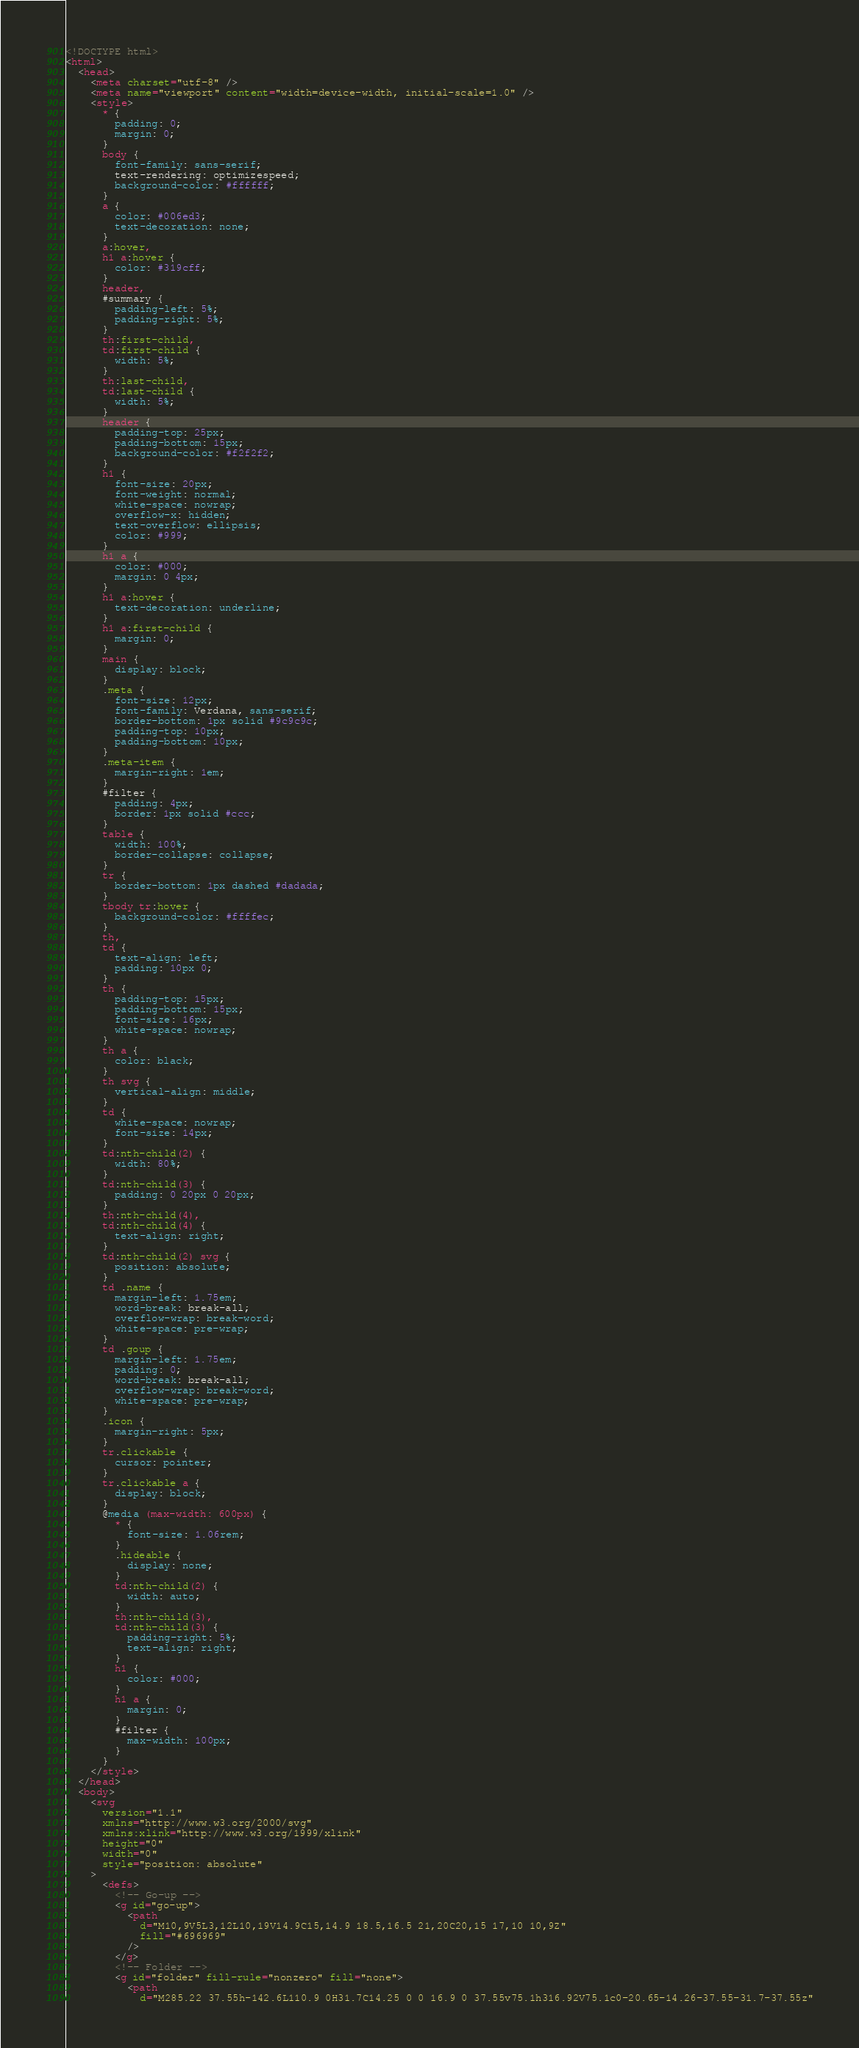Convert code to text. <code><loc_0><loc_0><loc_500><loc_500><_HTML_><!DOCTYPE html>
<html>
  <head>
    <meta charset="utf-8" />
    <meta name="viewport" content="width=device-width, initial-scale=1.0" />
    <style>
      * {
        padding: 0;
        margin: 0;
      }
      body {
        font-family: sans-serif;
        text-rendering: optimizespeed;
        background-color: #ffffff;
      }
      a {
        color: #006ed3;
        text-decoration: none;
      }
      a:hover,
      h1 a:hover {
        color: #319cff;
      }
      header,
      #summary {
        padding-left: 5%;
        padding-right: 5%;
      }
      th:first-child,
      td:first-child {
        width: 5%;
      }
      th:last-child,
      td:last-child {
        width: 5%;
      }
      header {
        padding-top: 25px;
        padding-bottom: 15px;
        background-color: #f2f2f2;
      }
      h1 {
        font-size: 20px;
        font-weight: normal;
        white-space: nowrap;
        overflow-x: hidden;
        text-overflow: ellipsis;
        color: #999;
      }
      h1 a {
        color: #000;
        margin: 0 4px;
      }
      h1 a:hover {
        text-decoration: underline;
      }
      h1 a:first-child {
        margin: 0;
      }
      main {
        display: block;
      }
      .meta {
        font-size: 12px;
        font-family: Verdana, sans-serif;
        border-bottom: 1px solid #9c9c9c;
        padding-top: 10px;
        padding-bottom: 10px;
      }
      .meta-item {
        margin-right: 1em;
      }
      #filter {
        padding: 4px;
        border: 1px solid #ccc;
      }
      table {
        width: 100%;
        border-collapse: collapse;
      }
      tr {
        border-bottom: 1px dashed #dadada;
      }
      tbody tr:hover {
        background-color: #ffffec;
      }
      th,
      td {
        text-align: left;
        padding: 10px 0;
      }
      th {
        padding-top: 15px;
        padding-bottom: 15px;
        font-size: 16px;
        white-space: nowrap;
      }
      th a {
        color: black;
      }
      th svg {
        vertical-align: middle;
      }
      td {
        white-space: nowrap;
        font-size: 14px;
      }
      td:nth-child(2) {
        width: 80%;
      }
      td:nth-child(3) {
        padding: 0 20px 0 20px;
      }
      th:nth-child(4),
      td:nth-child(4) {
        text-align: right;
      }
      td:nth-child(2) svg {
        position: absolute;
      }
      td .name {
        margin-left: 1.75em;
        word-break: break-all;
        overflow-wrap: break-word;
        white-space: pre-wrap;
      }
      td .goup {
        margin-left: 1.75em;
        padding: 0;
        word-break: break-all;
        overflow-wrap: break-word;
        white-space: pre-wrap;
      }
      .icon {
        margin-right: 5px;
      }
      tr.clickable {
        cursor: pointer;
      }
      tr.clickable a {
        display: block;
      }
      @media (max-width: 600px) {
        * {
          font-size: 1.06rem;
        }
        .hideable {
          display: none;
        }
        td:nth-child(2) {
          width: auto;
        }
        th:nth-child(3),
        td:nth-child(3) {
          padding-right: 5%;
          text-align: right;
        }
        h1 {
          color: #000;
        }
        h1 a {
          margin: 0;
        }
        #filter {
          max-width: 100px;
        }
      }
    </style>
  </head>
  <body>
    <svg
      version="1.1"
      xmlns="http://www.w3.org/2000/svg"
      xmlns:xlink="http://www.w3.org/1999/xlink"
      height="0"
      width="0"
      style="position: absolute"
    >
      <defs>
        <!-- Go-up -->
        <g id="go-up">
          <path
            d="M10,9V5L3,12L10,19V14.9C15,14.9 18.5,16.5 21,20C20,15 17,10 10,9Z"
            fill="#696969"
          />
        </g>
        <!-- Folder -->
        <g id="folder" fill-rule="nonzero" fill="none">
          <path
            d="M285.22 37.55h-142.6L110.9 0H31.7C14.25 0 0 16.9 0 37.55v75.1h316.92V75.1c0-20.65-14.26-37.55-31.7-37.55z"</code> 